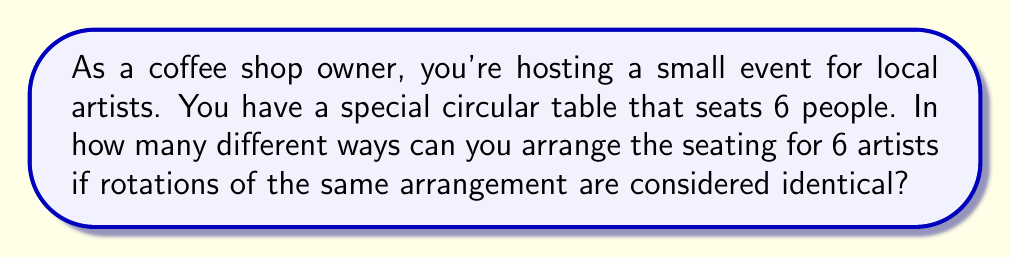Can you solve this math problem? Let's approach this step-by-step:

1) First, we need to recognize that this is a circular permutation problem. In circular permutations, rotations of the same arrangement are considered identical.

2) For a regular permutation of n distinct objects, we would have n! arrangements. In this case, that would be 6! = 720.

3) However, in a circular permutation, all rotations of a single arrangement are considered the same. For a table of 6 people, each arrangement can be rotated 6 different ways.

4) Therefore, we need to divide the total number of linear permutations by the number of rotations possible:

   $$\text{Number of arrangements} = \frac{\text{Linear permutations}}{\text{Number of rotations}} = \frac{6!}{6}$$

5) Let's calculate this:
   
   $$\frac{6!}{6} = \frac{720}{6} = 120$$

This means there are 120 unique ways to arrange 6 artists around your circular table.

[asy]
unitsize(2cm);
draw(circle((0,0),1));
for(int i=0; i<6; i++) {
  dot(dir(60*i));
  label("A" + string(i+1), 1.2*dir(60*i));
}
[/asy]

The diagram above shows one possible arrangement (A1, A2, A3, A4, A5, A6). Remember, rotating this arrangement (e.g., A2, A3, A4, A5, A6, A1) would be considered the same arrangement in a circular permutation.
Answer: 120 unique seating arrangements 